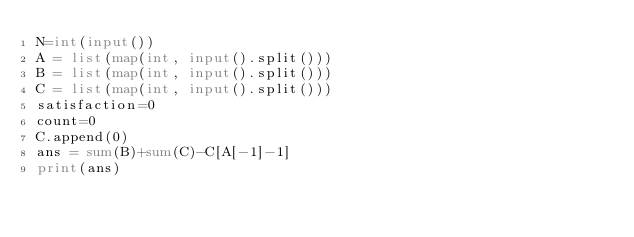Convert code to text. <code><loc_0><loc_0><loc_500><loc_500><_Python_>N=int(input())
A = list(map(int, input().split()))
B = list(map(int, input().split()))
C = list(map(int, input().split()))
satisfaction=0
count=0
C.append(0)
ans = sum(B)+sum(C)-C[A[-1]-1]
print(ans)</code> 